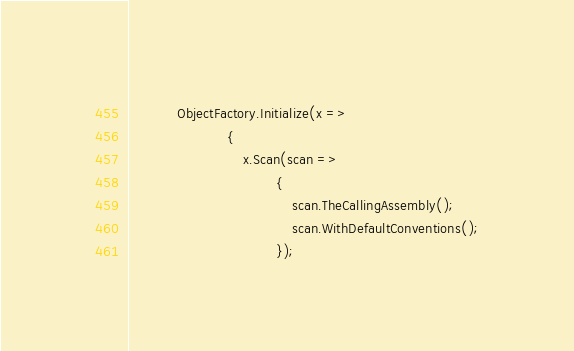Convert code to text. <code><loc_0><loc_0><loc_500><loc_500><_C#_>            ObjectFactory.Initialize(x =>
                        {
                            x.Scan(scan =>
                                    {
                                        scan.TheCallingAssembly();
                                        scan.WithDefaultConventions();
                                    });</code> 